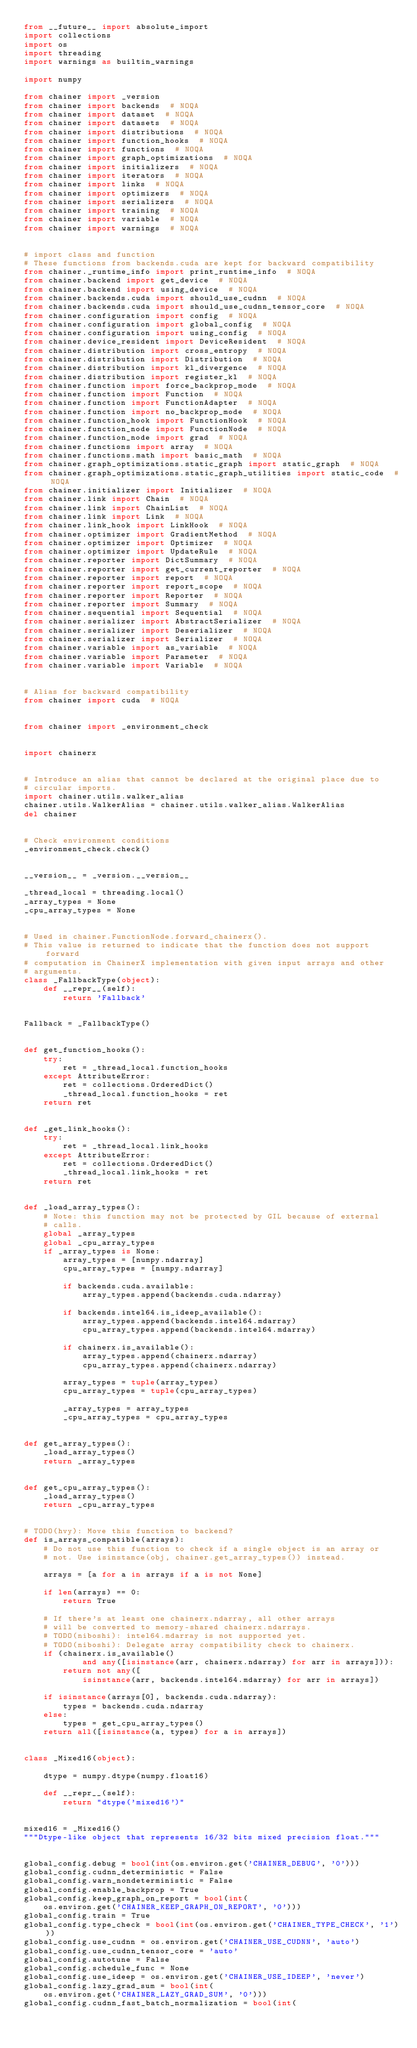<code> <loc_0><loc_0><loc_500><loc_500><_Python_>from __future__ import absolute_import
import collections
import os
import threading
import warnings as builtin_warnings

import numpy

from chainer import _version
from chainer import backends  # NOQA
from chainer import dataset  # NOQA
from chainer import datasets  # NOQA
from chainer import distributions  # NOQA
from chainer import function_hooks  # NOQA
from chainer import functions  # NOQA
from chainer import graph_optimizations  # NOQA
from chainer import initializers  # NOQA
from chainer import iterators  # NOQA
from chainer import links  # NOQA
from chainer import optimizers  # NOQA
from chainer import serializers  # NOQA
from chainer import training  # NOQA
from chainer import variable  # NOQA
from chainer import warnings  # NOQA


# import class and function
# These functions from backends.cuda are kept for backward compatibility
from chainer._runtime_info import print_runtime_info  # NOQA
from chainer.backend import get_device  # NOQA
from chainer.backend import using_device  # NOQA
from chainer.backends.cuda import should_use_cudnn  # NOQA
from chainer.backends.cuda import should_use_cudnn_tensor_core  # NOQA
from chainer.configuration import config  # NOQA
from chainer.configuration import global_config  # NOQA
from chainer.configuration import using_config  # NOQA
from chainer.device_resident import DeviceResident  # NOQA
from chainer.distribution import cross_entropy  # NOQA
from chainer.distribution import Distribution  # NOQA
from chainer.distribution import kl_divergence  # NOQA
from chainer.distribution import register_kl  # NOQA
from chainer.function import force_backprop_mode  # NOQA
from chainer.function import Function  # NOQA
from chainer.function import FunctionAdapter  # NOQA
from chainer.function import no_backprop_mode  # NOQA
from chainer.function_hook import FunctionHook  # NOQA
from chainer.function_node import FunctionNode  # NOQA
from chainer.function_node import grad  # NOQA
from chainer.functions import array  # NOQA
from chainer.functions.math import basic_math  # NOQA
from chainer.graph_optimizations.static_graph import static_graph  # NOQA
from chainer.graph_optimizations.static_graph_utilities import static_code  # NOQA
from chainer.initializer import Initializer  # NOQA
from chainer.link import Chain  # NOQA
from chainer.link import ChainList  # NOQA
from chainer.link import Link  # NOQA
from chainer.link_hook import LinkHook  # NOQA
from chainer.optimizer import GradientMethod  # NOQA
from chainer.optimizer import Optimizer  # NOQA
from chainer.optimizer import UpdateRule  # NOQA
from chainer.reporter import DictSummary  # NOQA
from chainer.reporter import get_current_reporter  # NOQA
from chainer.reporter import report  # NOQA
from chainer.reporter import report_scope  # NOQA
from chainer.reporter import Reporter  # NOQA
from chainer.reporter import Summary  # NOQA
from chainer.sequential import Sequential  # NOQA
from chainer.serializer import AbstractSerializer  # NOQA
from chainer.serializer import Deserializer  # NOQA
from chainer.serializer import Serializer  # NOQA
from chainer.variable import as_variable  # NOQA
from chainer.variable import Parameter  # NOQA
from chainer.variable import Variable  # NOQA


# Alias for backward compatibility
from chainer import cuda  # NOQA


from chainer import _environment_check


import chainerx


# Introduce an alias that cannot be declared at the original place due to
# circular imports.
import chainer.utils.walker_alias
chainer.utils.WalkerAlias = chainer.utils.walker_alias.WalkerAlias
del chainer


# Check environment conditions
_environment_check.check()


__version__ = _version.__version__

_thread_local = threading.local()
_array_types = None
_cpu_array_types = None


# Used in chainer.FunctionNode.forward_chainerx().
# This value is returned to indicate that the function does not support forward
# computation in ChainerX implementation with given input arrays and other
# arguments.
class _FallbackType(object):
    def __repr__(self):
        return 'Fallback'


Fallback = _FallbackType()


def get_function_hooks():
    try:
        ret = _thread_local.function_hooks
    except AttributeError:
        ret = collections.OrderedDict()
        _thread_local.function_hooks = ret
    return ret


def _get_link_hooks():
    try:
        ret = _thread_local.link_hooks
    except AttributeError:
        ret = collections.OrderedDict()
        _thread_local.link_hooks = ret
    return ret


def _load_array_types():
    # Note: this function may not be protected by GIL because of external
    # calls.
    global _array_types
    global _cpu_array_types
    if _array_types is None:
        array_types = [numpy.ndarray]
        cpu_array_types = [numpy.ndarray]

        if backends.cuda.available:
            array_types.append(backends.cuda.ndarray)

        if backends.intel64.is_ideep_available():
            array_types.append(backends.intel64.mdarray)
            cpu_array_types.append(backends.intel64.mdarray)

        if chainerx.is_available():
            array_types.append(chainerx.ndarray)
            cpu_array_types.append(chainerx.ndarray)

        array_types = tuple(array_types)
        cpu_array_types = tuple(cpu_array_types)

        _array_types = array_types
        _cpu_array_types = cpu_array_types


def get_array_types():
    _load_array_types()
    return _array_types


def get_cpu_array_types():
    _load_array_types()
    return _cpu_array_types


# TODO(hvy): Move this function to backend?
def is_arrays_compatible(arrays):
    # Do not use this function to check if a single object is an array or
    # not. Use isinstance(obj, chainer.get_array_types()) instead.

    arrays = [a for a in arrays if a is not None]

    if len(arrays) == 0:
        return True

    # If there's at least one chainerx.ndarray, all other arrays
    # will be converted to memory-shared chainerx.ndarrays.
    # TODO(niboshi): intel64.mdarray is not supported yet.
    # TODO(niboshi): Delegate array compatibility check to chainerx.
    if (chainerx.is_available()
            and any([isinstance(arr, chainerx.ndarray) for arr in arrays])):
        return not any([
            isinstance(arr, backends.intel64.mdarray) for arr in arrays])

    if isinstance(arrays[0], backends.cuda.ndarray):
        types = backends.cuda.ndarray
    else:
        types = get_cpu_array_types()
    return all([isinstance(a, types) for a in arrays])


class _Mixed16(object):

    dtype = numpy.dtype(numpy.float16)

    def __repr__(self):
        return "dtype('mixed16')"


mixed16 = _Mixed16()
"""Dtype-like object that represents 16/32 bits mixed precision float."""


global_config.debug = bool(int(os.environ.get('CHAINER_DEBUG', '0')))
global_config.cudnn_deterministic = False
global_config.warn_nondeterministic = False
global_config.enable_backprop = True
global_config.keep_graph_on_report = bool(int(
    os.environ.get('CHAINER_KEEP_GRAPH_ON_REPORT', '0')))
global_config.train = True
global_config.type_check = bool(int(os.environ.get('CHAINER_TYPE_CHECK', '1')))
global_config.use_cudnn = os.environ.get('CHAINER_USE_CUDNN', 'auto')
global_config.use_cudnn_tensor_core = 'auto'
global_config.autotune = False
global_config.schedule_func = None
global_config.use_ideep = os.environ.get('CHAINER_USE_IDEEP', 'never')
global_config.lazy_grad_sum = bool(int(
    os.environ.get('CHAINER_LAZY_GRAD_SUM', '0')))
global_config.cudnn_fast_batch_normalization = bool(int(</code> 